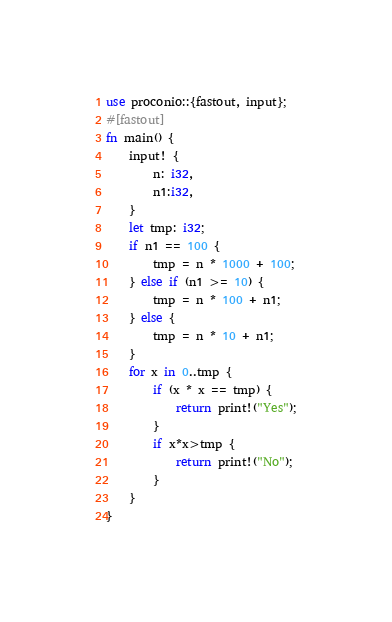<code> <loc_0><loc_0><loc_500><loc_500><_Rust_>use proconio::{fastout, input};
#[fastout]
fn main() {
    input! {
        n: i32,
        n1:i32,
    }
    let tmp: i32;
    if n1 == 100 {
        tmp = n * 1000 + 100;
    } else if (n1 >= 10) {
        tmp = n * 100 + n1;
    } else {
        tmp = n * 10 + n1;
    }
    for x in 0..tmp {
        if (x * x == tmp) {
            return print!("Yes");
        }
        if x*x>tmp {
            return print!("No");
        }
    }
}
</code> 